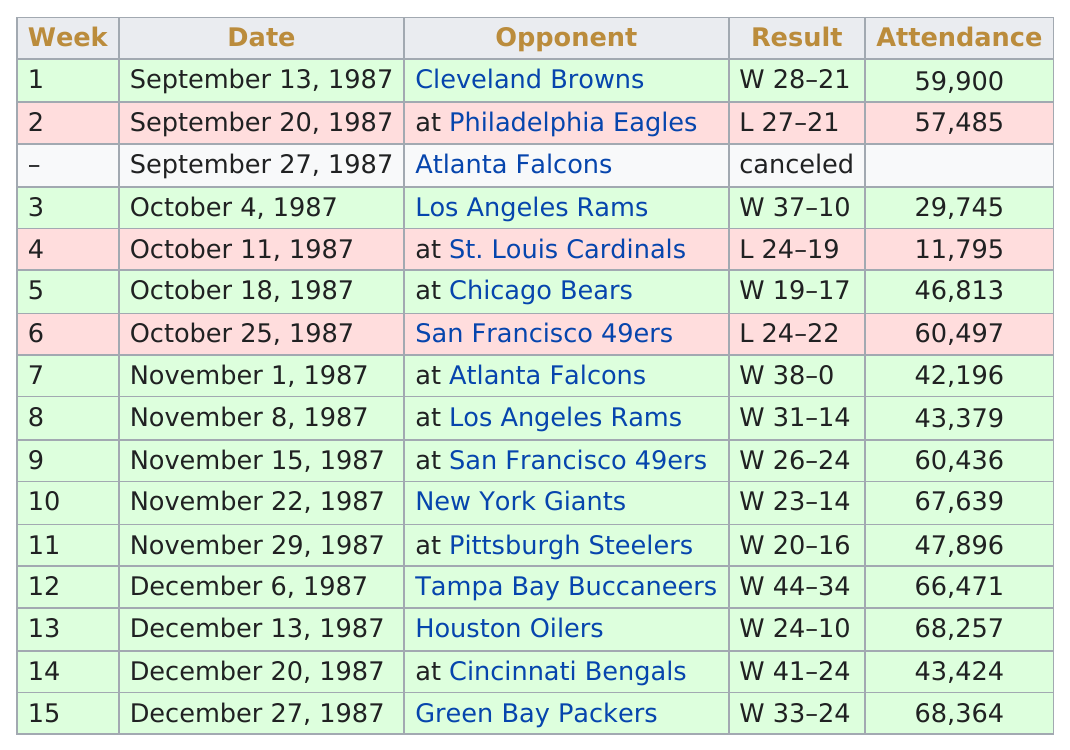List a handful of essential elements in this visual. The total wins for week 7 are 4. The total number of losses was 3. The least amount of attendance for a game in November was 42,196. Their last loss occurred in week 6. In November, the number of games scheduled was 5. 